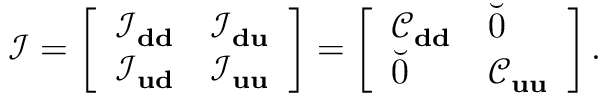Convert formula to latex. <formula><loc_0><loc_0><loc_500><loc_500>\mathcal { I } = \left [ \begin{array} { l l } { \mathcal { I } _ { d d } } & { \mathcal { I } _ { d u } } \\ { \mathcal { I } _ { u d } } & { \mathcal { I } _ { u u } } \end{array} \right ] = \left [ \begin{array} { l l } { \mathcal { C } _ { d d } } & { \breve { 0 } } \\ { \breve { 0 } } & { \mathcal { C } _ { u u } } \end{array} \right ] .</formula> 